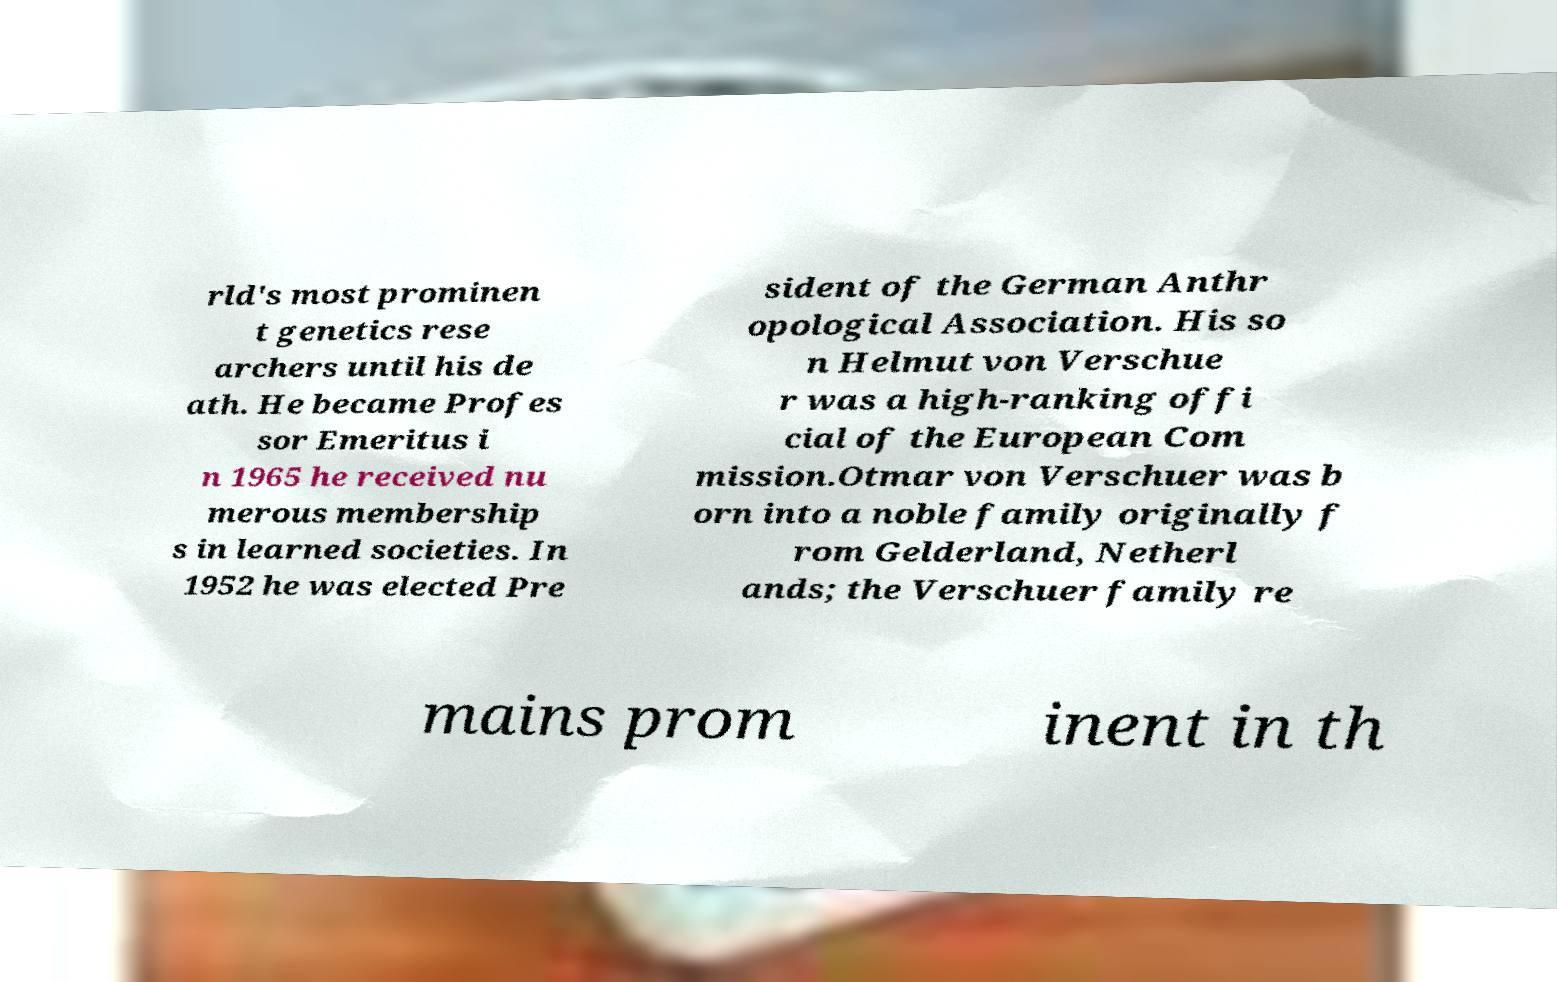For documentation purposes, I need the text within this image transcribed. Could you provide that? rld's most prominen t genetics rese archers until his de ath. He became Profes sor Emeritus i n 1965 he received nu merous membership s in learned societies. In 1952 he was elected Pre sident of the German Anthr opological Association. His so n Helmut von Verschue r was a high-ranking offi cial of the European Com mission.Otmar von Verschuer was b orn into a noble family originally f rom Gelderland, Netherl ands; the Verschuer family re mains prom inent in th 